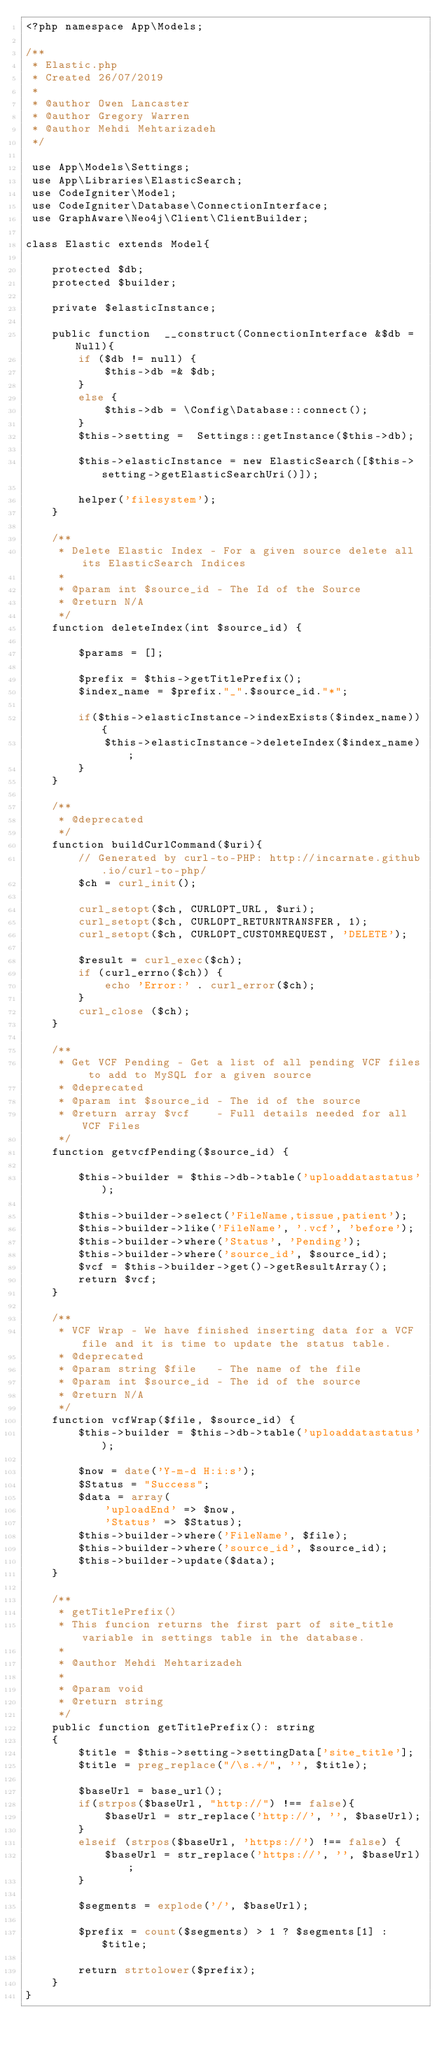<code> <loc_0><loc_0><loc_500><loc_500><_PHP_><?php namespace App\Models;

/**
 * Elastic.php
 * Created 26/07/2019
 * 
 * @author Owen Lancaster 
 * @author Gregory Warren
 * @author Mehdi Mehtarizadeh
 */

 use App\Models\Settings;
 use App\Libraries\ElasticSearch;
 use CodeIgniter\Model;
 use CodeIgniter\Database\ConnectionInterface;
 use GraphAware\Neo4j\Client\ClientBuilder;

class Elastic extends Model{

    protected $db;
    protected $builder;

    private $elasticInstance;

    public function  __construct(ConnectionInterface &$db = Null){
        if ($db != null) {
            $this->db =& $db;
        }
        else {
            $this->db = \Config\Database::connect();
        }
        $this->setting =  Settings::getInstance($this->db);

        $this->elasticInstance = new ElasticSearch([$this->setting->getElasticSearchUri()]);

        helper('filesystem');
    }

    /**
     * Delete Elastic Index - For a given source delete all its ElasticSearch Indices
     *
     * @param int $source_id - The Id of the Source
     * @return N/A
     */
    function deleteIndex(int $source_id) {

        $params = [];

        $prefix = $this->getTitlePrefix();
        $index_name = $prefix."_".$source_id."*";	    

        if($this->elasticInstance->indexExists($index_name)){
            $this->elasticInstance->deleteIndex($index_name);
        }
    }

    /**
     * @deprecated
     */
    function buildCurlCommand($uri){
        // Generated by curl-to-PHP: http://incarnate.github.io/curl-to-php/
        $ch = curl_init();

        curl_setopt($ch, CURLOPT_URL, $uri);
        curl_setopt($ch, CURLOPT_RETURNTRANSFER, 1);
        curl_setopt($ch, CURLOPT_CUSTOMREQUEST, 'DELETE');

        $result = curl_exec($ch);
        if (curl_errno($ch)) {
            echo 'Error:' . curl_error($ch);
        }
        curl_close ($ch);
    }

    /**
     * Get VCF Pending - Get a list of all pending VCF files to add to MySQL for a given source
     * @deprecated
     * @param int $source_id - The id of the source
     * @return array $vcf    - Full details needed for all VCF Files
     */
    function getvcfPending($source_id) {

        $this->builder = $this->db->table('uploaddatastatus');

        $this->builder->select('FileName,tissue,patient');
        $this->builder->like('FileName', '.vcf', 'before'); 
        $this->builder->where('Status', 'Pending');
        $this->builder->where('source_id', $source_id);
        $vcf = $this->builder->get()->getResultArray();
        return $vcf;
    }

    /**
     * VCF Wrap - We have finished inserting data for a VCF file and it is time to update the status table. 
     * @deprecated
     * @param string $file   - The name of the file
     * @param int $source_id - The id of the source
     * @return N/A 
     */
    function vcfWrap($file, $source_id) {
        $this->builder = $this->db->table('uploaddatastatus');

        $now = date('Y-m-d H:i:s');
        $Status = "Success";
        $data = array(
            'uploadEnd' => $now,
            'Status' => $Status);
        $this->builder->where('FileName', $file);
        $this->builder->where('source_id', $source_id);
        $this->builder->update($data);
    }

    /**
     * getTitlePrefix()
     * This funcion returns the first part of site_title variable in settings table in the database.
     * 
     * @author Mehdi Mehtarizadeh
     * 
     * @param void 
     * @return string
     */
    public function getTitlePrefix(): string
    {
        $title = $this->setting->settingData['site_title'];
        $title = preg_replace("/\s.+/", '', $title);

        $baseUrl = base_url();
        if(strpos($baseUrl, "http://") !== false){
            $baseUrl = str_replace('http://', '', $baseUrl);
        }
        elseif (strpos($baseUrl, 'https://') !== false) {
            $baseUrl = str_replace('https://', '', $baseUrl);
        }

        $segments = explode('/', $baseUrl);

        $prefix = count($segments) > 1 ? $segments[1] : $title;
 
        return strtolower($prefix);
    }
}</code> 